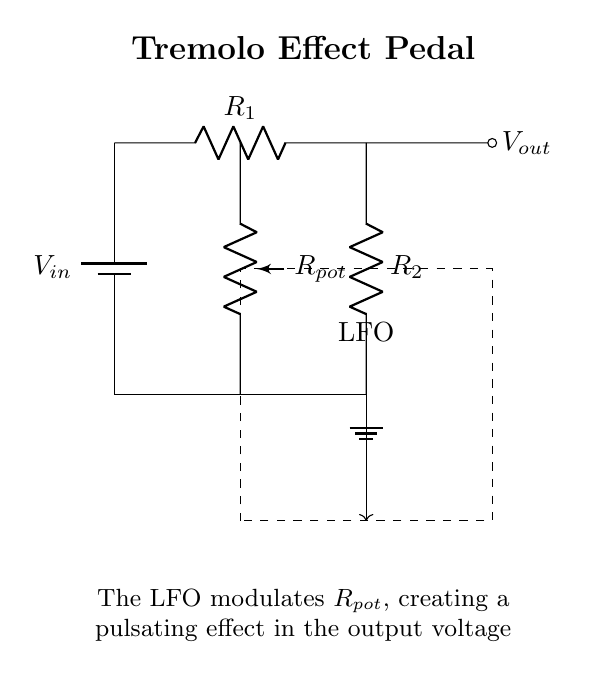What is the power supply voltage in the circuit? The power supply voltage is denoted as Vin, which is the potential source for the circuit. However, the specific value is not given in the diagram, so it remains as Vin.
Answer: Vin What does R1 represent in the circuit? In this voltage divider circuit, R1 represents one of the resistors that determine the output voltage based on the voltage divider rule. It is a resistor labeled R1 located at the top of the divider.
Answer: R1 What component modulates Rpot? The LFO (Low-Frequency Oscillator) modulates Rpot to create the tremolo effect. This modulation is shown in the circuit by an arrow pointing from the output of the voltage divider to the LFO rectangle, indicating influence.
Answer: LFO What is the function of Rpot in the circuit? Rpot functions as a variable resistor or potentiometer that allows the user to adjust the effect's intensity, creating different pulsating sounds in the output voltage based on its position.
Answer: Variable resistor What relationship does Vout have with R1 and R2? Vout is determined by the voltage divider equation, which states Vout is the fraction of Vin based on the proportion of R2 to the total resistance (R1 + R2). Thus, it reflects the division of voltage between these resistors.
Answer: Voltage division What can be inferred about the tremolo effect based on the circuit design? The tremolo effect is created through the modulation of the resistance of Rpot by the LFO, which changes how much of Vin is passed to Vout, resulting in a pulsating sound. The interaction of the LFO and Rpot is critical for achieving this effect.
Answer: Pulsating sound 